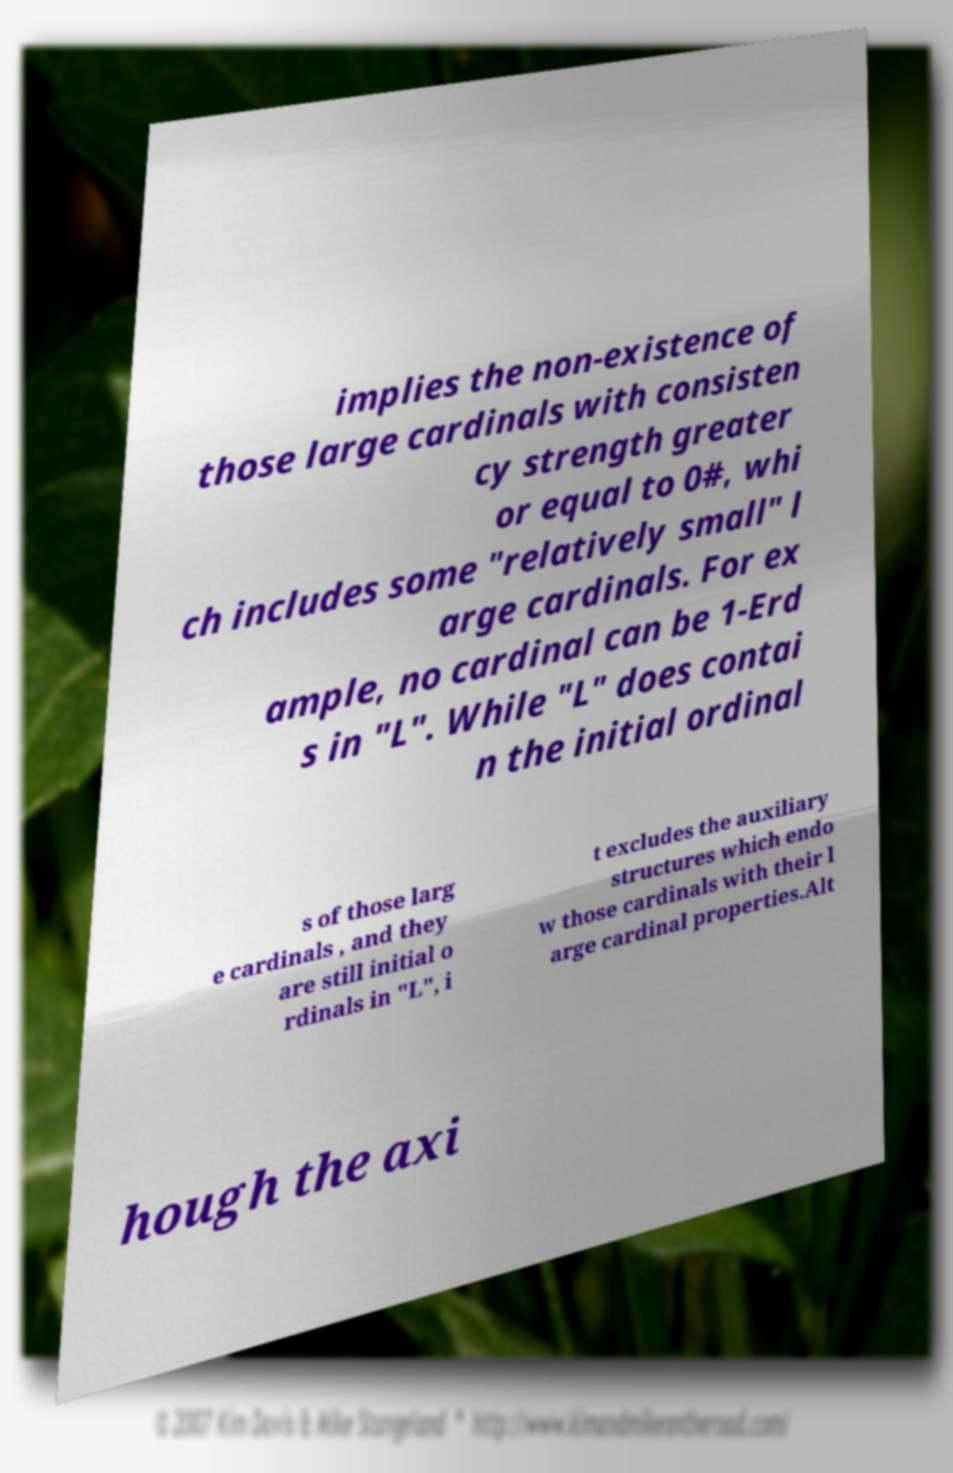Please read and relay the text visible in this image. What does it say? implies the non-existence of those large cardinals with consisten cy strength greater or equal to 0#, whi ch includes some "relatively small" l arge cardinals. For ex ample, no cardinal can be 1-Erd s in "L". While "L" does contai n the initial ordinal s of those larg e cardinals , and they are still initial o rdinals in "L", i t excludes the auxiliary structures which endo w those cardinals with their l arge cardinal properties.Alt hough the axi 